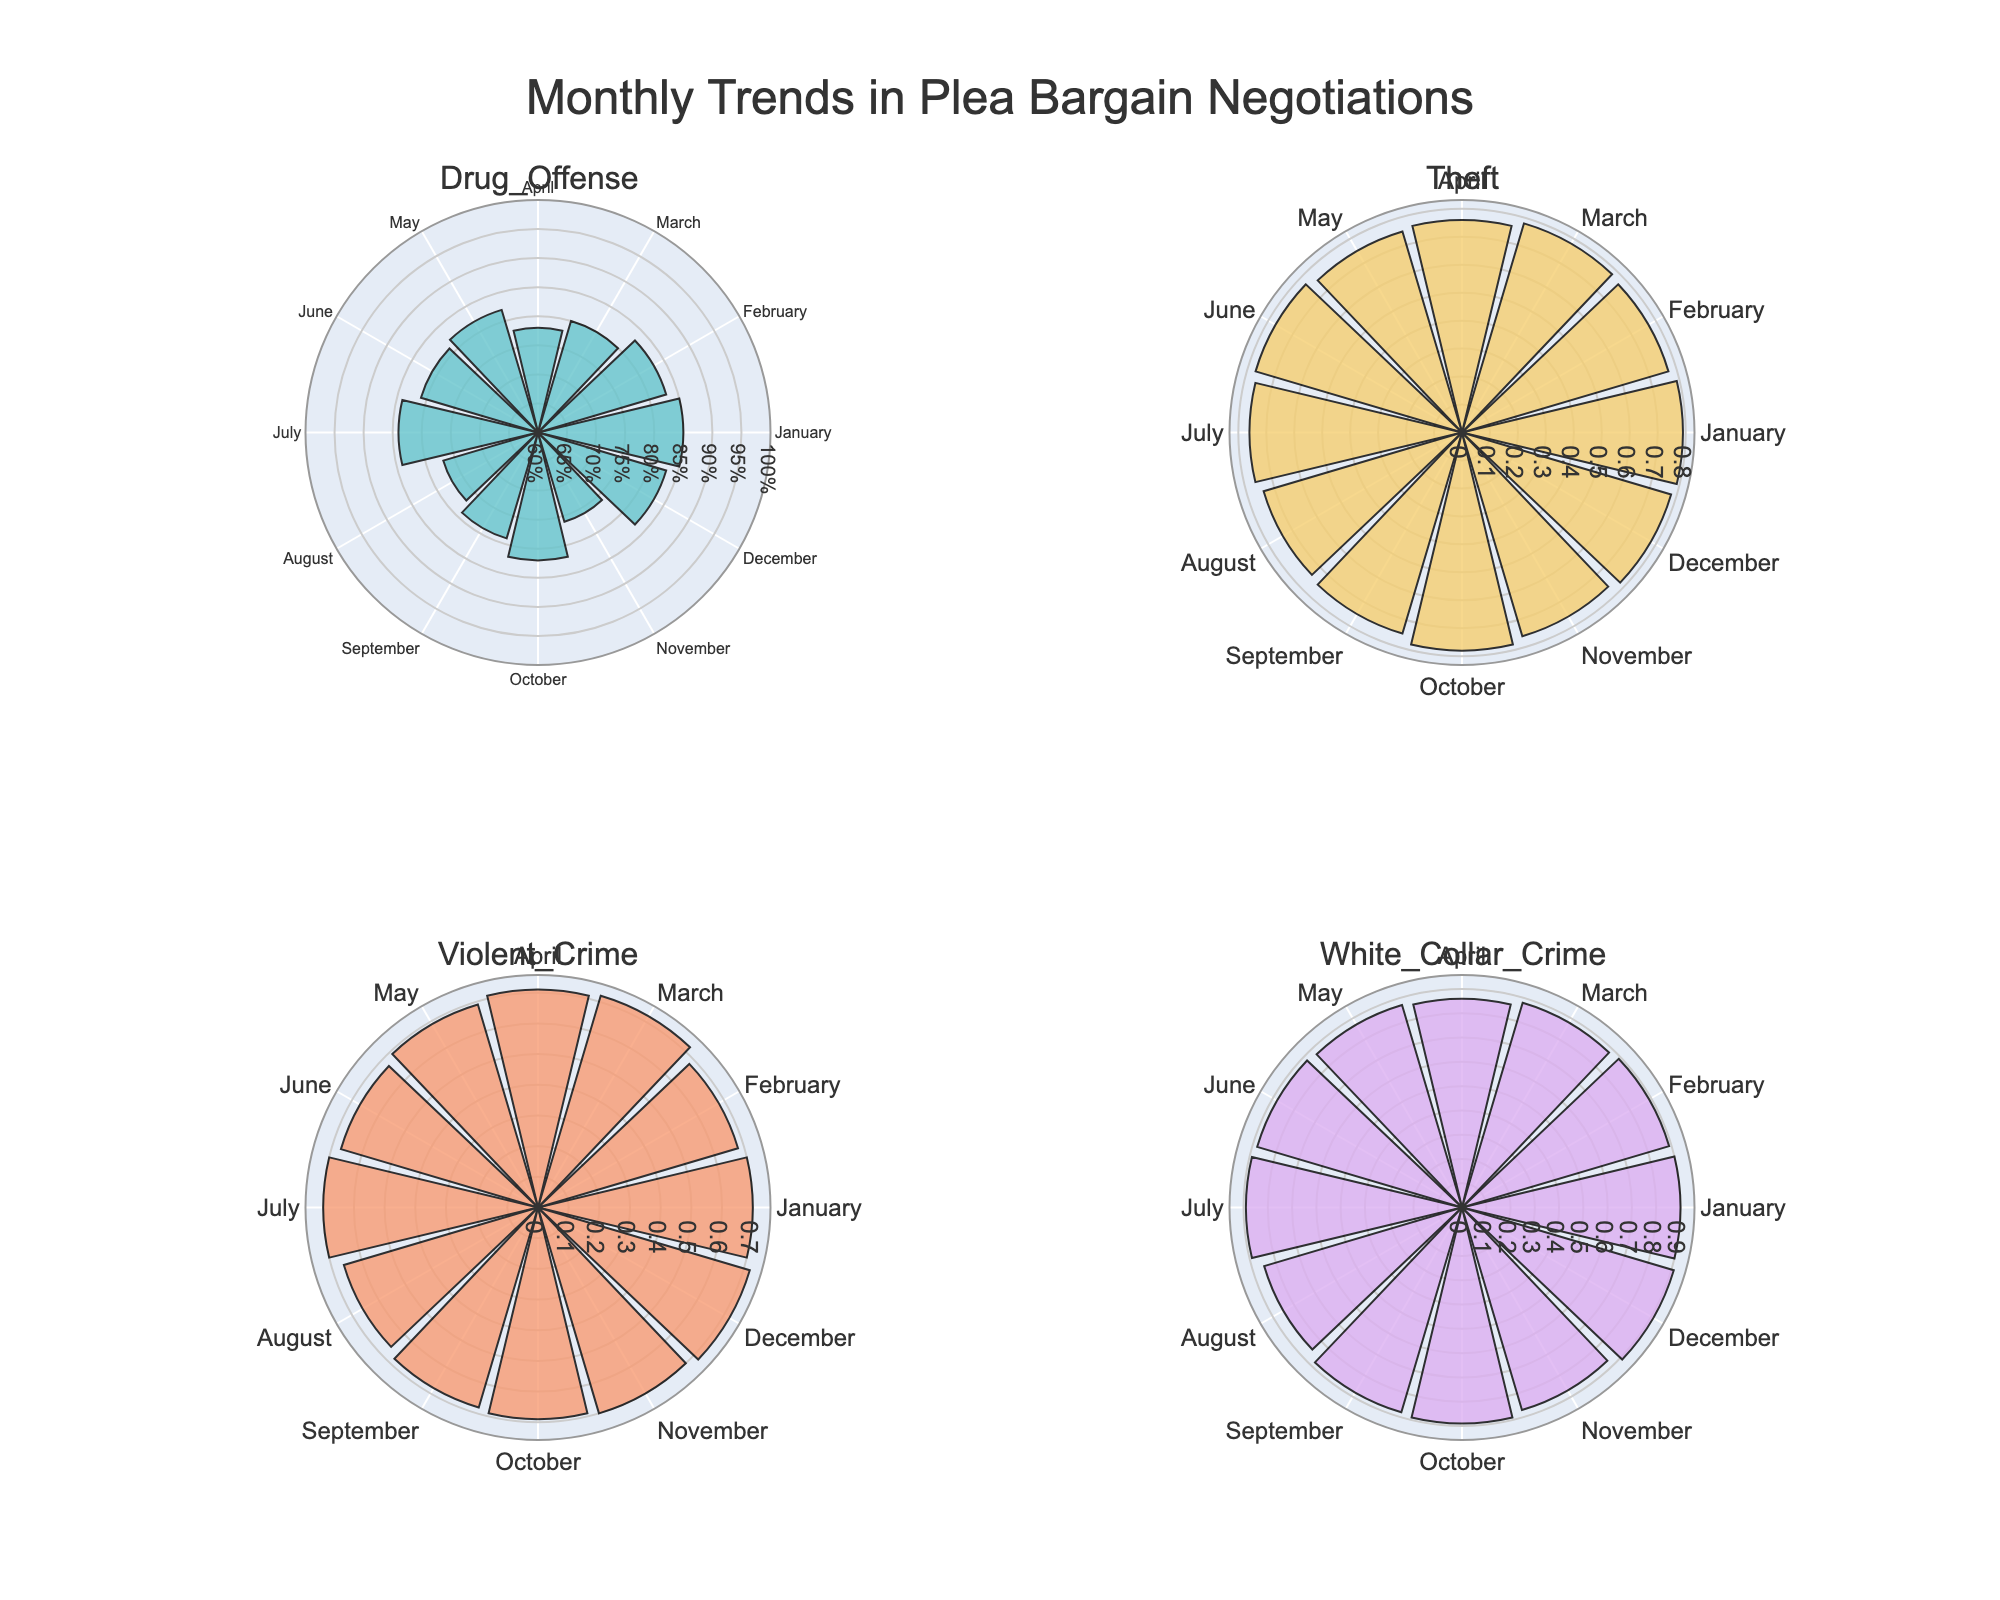What is the title of the figure? The title of the figure is typically placed at the top. Reading the top of the rose chart, we observe the title "Monthly Trends in Plea Bargain Negotiations".
Answer: Monthly Trends in Plea Bargain Negotiations What categories of cases are included in the figure? The subplot titles generally signify the different categories. Reading through them, we see "Drug Offense", "White Collar Crime", "Violent Crime", and "Theft".
Answer: Drug Offense, White Collar Crime, Violent Crime, Theft Which month shows the lowest settlement rate for Violent Crime cases? By observing the bar lengths in the polar plot for Violent Crime, we can see August has the shortest bar.
Answer: August Between Drug Offense and White Collar Crime, in which month is the settlement rate closest to each other? Compare the settlement rates month by month between Drug Offense and White Collar Crime to see the smallest difference. Both types have the same rate in June at 0.81 and 0.88, respectively.
Answer: June What is the difference in settlement rates of Theft cases between May and December? The bars in the polar plot for Theft cases indicate that May has a settlement rate of 0.75 and December has 0.78. Subtracting these gives 0.78 - 0.75.
Answer: 0.03 Which case type has the highest overall settlement rate in any month? Look at the longest bar across all the subplots. The longest bar is for White Collar Crime in December with a rate of 0.91.
Answer: White Collar Crime in December How does the settlement rate for Drug Offense cases in January compare to November? For Drug Offense, the bar representing January is longer than the one for November, indicating a higher settlement rate of 0.85 in January compared to 0.76 in November.
Answer: January is higher than November What is the average settlement rate for Violent Crime cases in February, April, and October? Add the rates for Violent Crime in February (0.68), April (0.71), and October (0.69). Then divide by 3. So, (0.68 + 0.71 + 0.69) / 3.
Answer: 0.693 Which month has the most variation in settlement rates across different case types? By visually comparing the bar lengths for each month across the four subplots, August shows the most variability with rates 0.77 (Drug Offense), 0.85 (White Collar Crime), 0.66 (Violent Crime), and 0.74 (Theft).
Answer: August In which case type does the settlement rate show a downward trend from January to June? Following the bar lengths from January to June in each subplot, Drug Offense shows a downward trend: 0.85, 0.83, 0.80, 0.78, 0.82, 0.81.
Answer: Drug Offense 